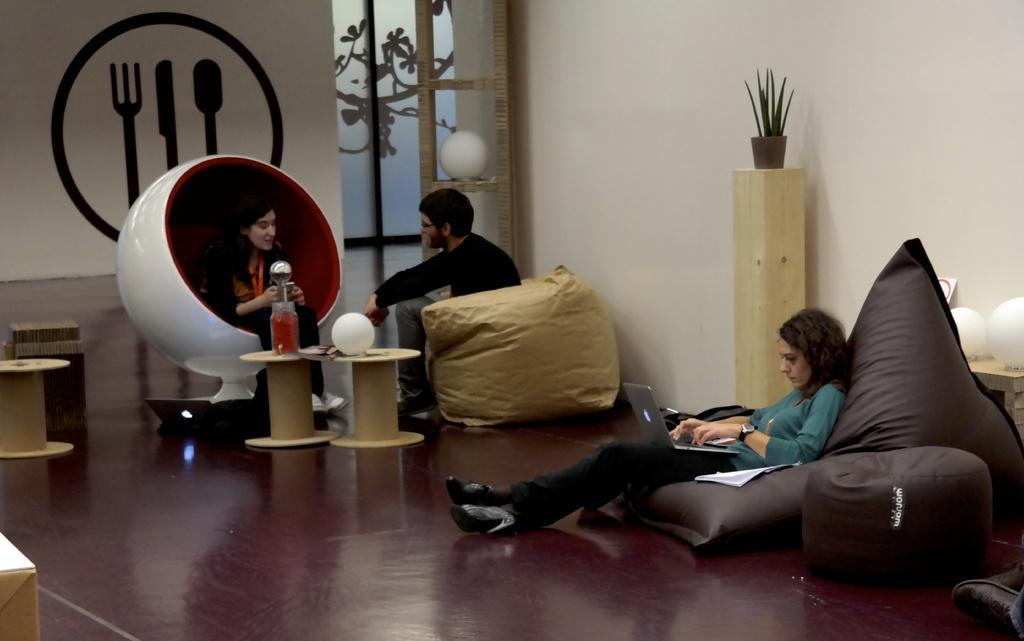Can you describe this image briefly? In this picture I can see few people seated and I can see a woman seated and working on a laptop and I can see a man and woman seated and speaking to each other and I can see a flower and few ball lights on the tables and I can see a plant and painting on the wall. 